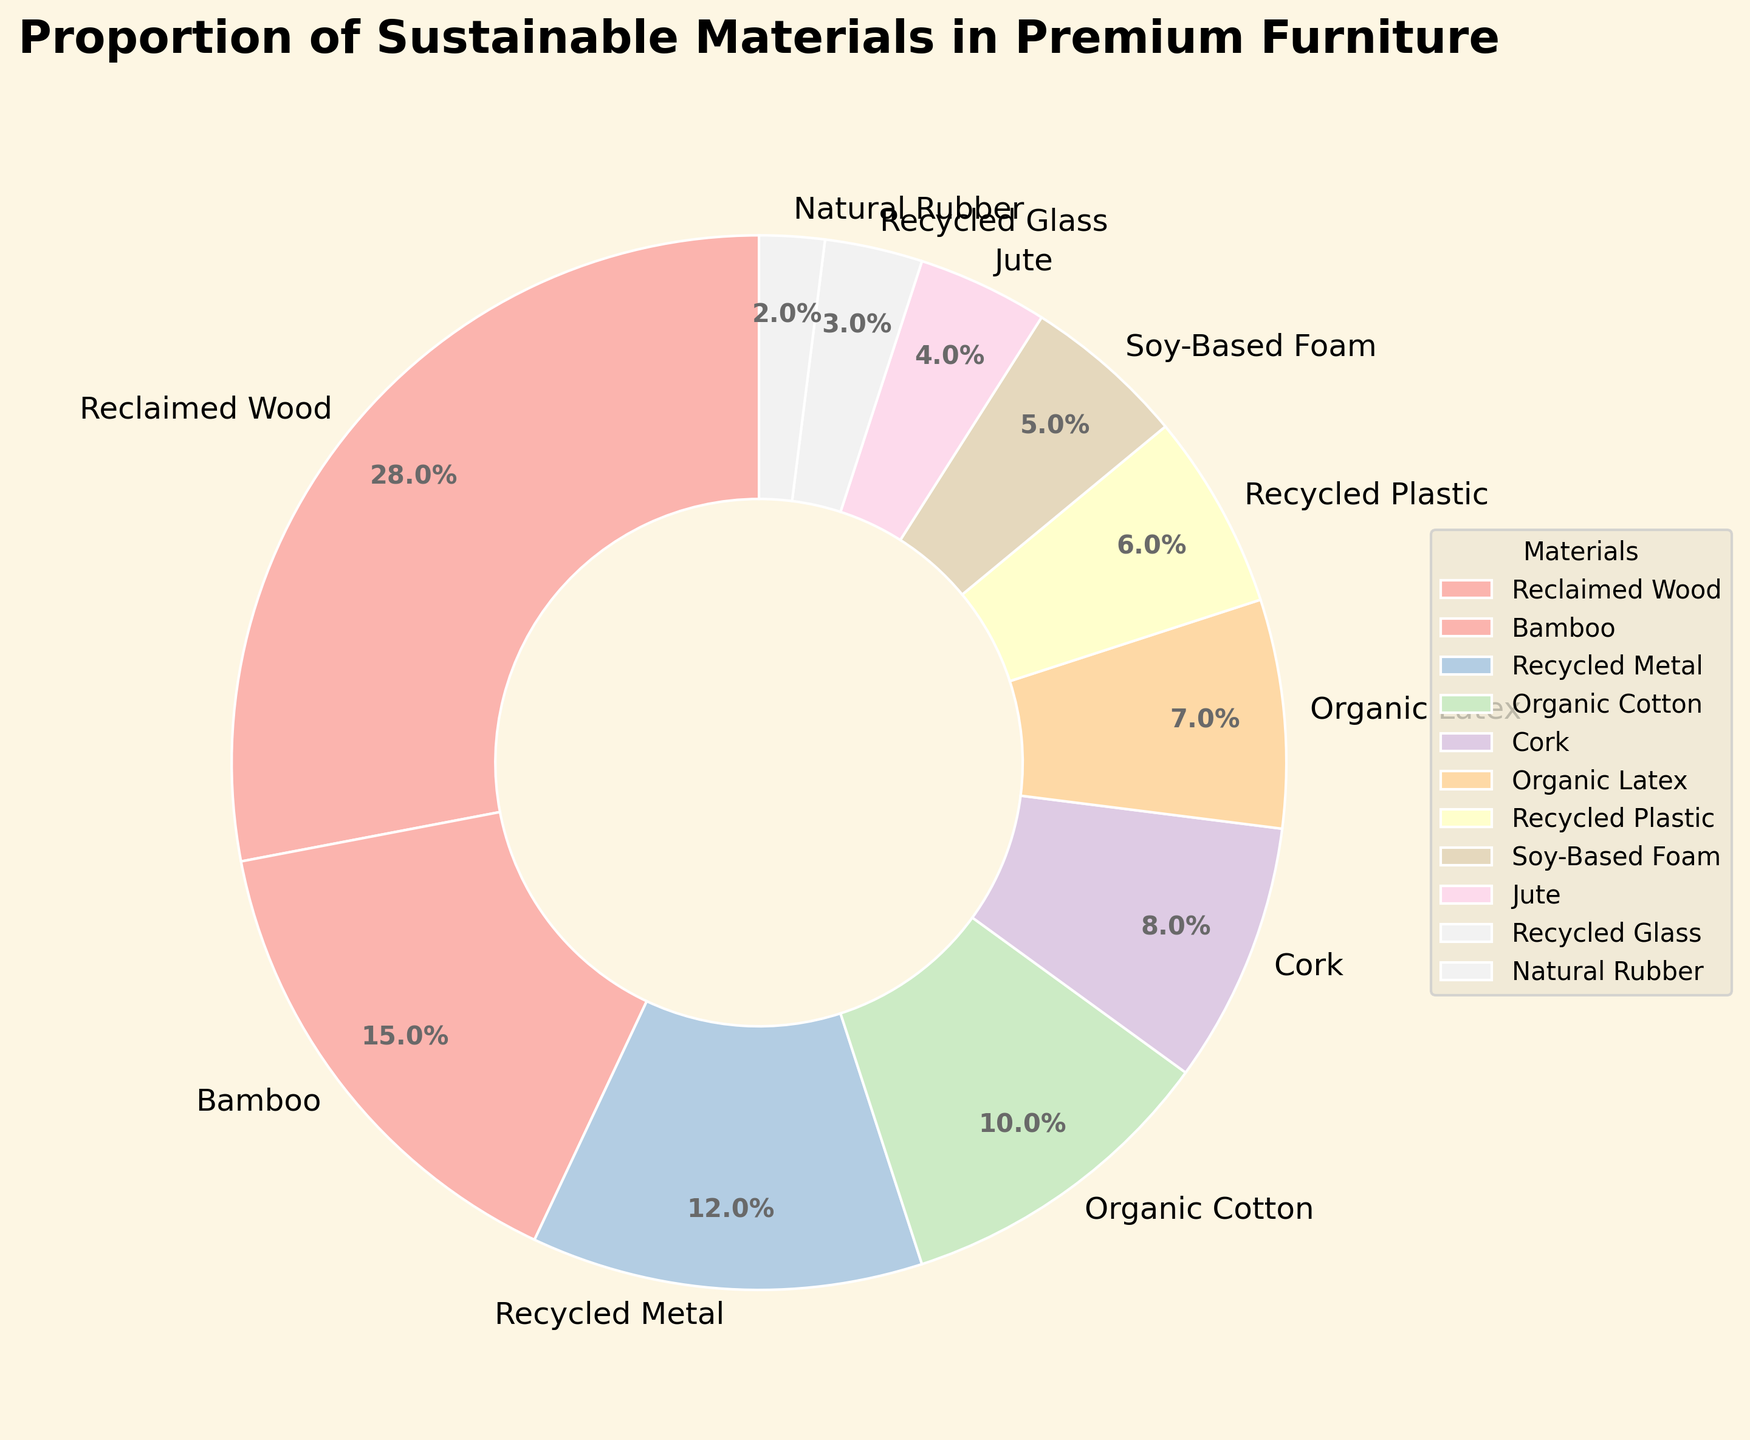what is the percentage of the most sustainable material used in premium furniture manufacturing? The figure shows the percentage of different materials. The highest percentage is for Reclaimed Wood at 28%.
Answer: 28% Which material has the smallest share? By looking at the smallest segment in the pie chart, Natural Rubber has the smallest share at 2%.
Answer: 2% How many materials have a share of less than 10%? Count the segments in the pie chart where the percentage is less than 10%: Recycled Metal (12%), Organic Cotton (10%), Cork (8%), Organic Latex (7%), Recycled Plastic (6%), Soy-Based Foam (5%), Jute (4%), Recycled Glass (3%), Natural Rubber (2%). There are 8 materials.
Answer: 8 What is the combined percentage of Bamboo and Organic Cotton? Bamboo accounts for 15% and Organic Cotton accounts for 10%. The combined percentage is 15% + 10% = 25%.
Answer: 25% Which materials have a greater percentage than Cork? The figure shows that Cork has 8%. Materials greater than 8% are Reclaimed Wood (28%), Bamboo (15%), and Recycled Metal (12%).
Answer: Reclaimed Wood, Bamboo, Recycled Metal What color represents Organic Latex in the pie chart and what is its percentage? The pie chart uses different colors for each material. Look for Organic Latex in the legend and match the color; its percentage is 7%.
Answer: [Color identified in the legend], 7% What is the difference in percentage between Reclaimed Wood and Soy-Based Foam? Reclaimed Wood is 28%, and Soy-Based Foam is 5%. The difference is 28% - 5% = 23%.
Answer: 23% Are there more materials used with percentages between 5% and 10% than between 1% and 5%? Identify the materials in each range. Between 5% and 10%: Organic Cotton (10%), Cork (8%), Organic Latex (7%), Recycled Plastic (6%), Soy-Based Foam (5%). Between 1% and 5%: Jute (4%), Recycled Glass (3%), Natural Rubber (2%). There are 5 materials in the first range and 3 in the second.
Answer: Yes What is the average percentage of the materials shown in the chart? Sum all percentages: 28% + 15% + 12% + 10% + 8% + 7% + 6% + 5% + 4% + 3% + 2% = 100%. The average percentage is 100% / 11 ≈ 9.09%.
Answer: 9.09% Which material segments appear to be roughly the same size in the pie chart? Compare the pie chart segments visually. Organic Latex (7%) and Recycled Plastic (6%) appear to be roughly the same size.
Answer: Organic Latex and Recycled Plastic 